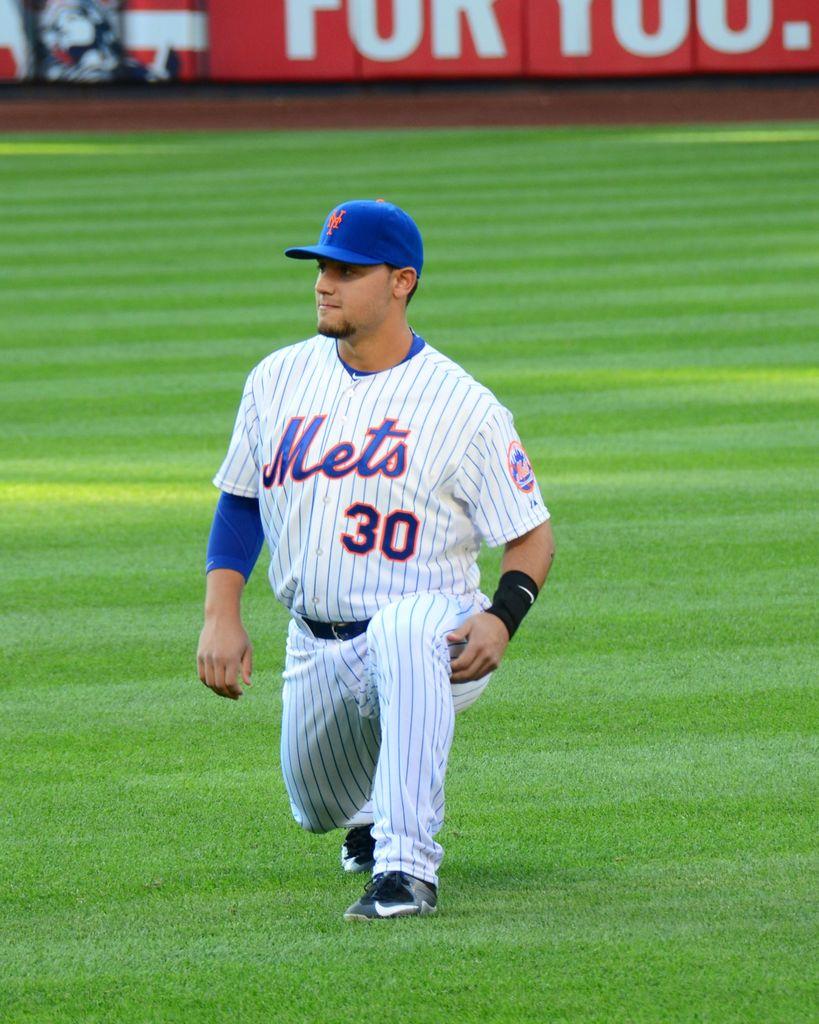What number is on the uniform?
Provide a short and direct response. 30. 